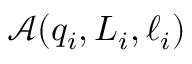Convert formula to latex. <formula><loc_0><loc_0><loc_500><loc_500>\ m a t h s c r { A } \, \left ( q _ { i } , L _ { i } , \ell _ { i } \right )</formula> 